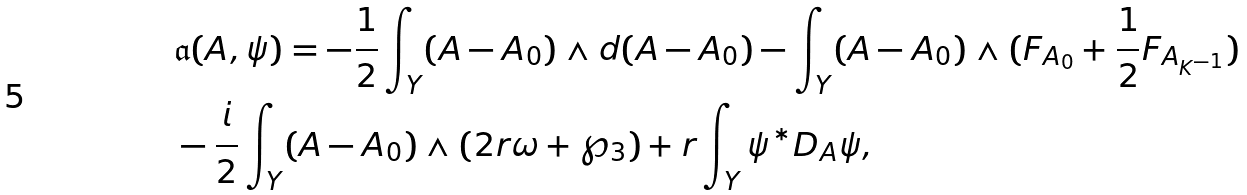Convert formula to latex. <formula><loc_0><loc_0><loc_500><loc_500>& \mathfrak { a } ( A , \psi ) = - \frac { 1 } { 2 } \int _ { Y } ( A - A _ { 0 } ) \wedge d ( A - A _ { 0 } ) - \int _ { Y } ( A - A _ { 0 } ) \wedge ( F _ { A _ { 0 } } + \frac { 1 } { 2 } F _ { A _ { K ^ { - 1 } } } ) \\ & - \frac { i } { 2 } \int _ { Y } ( A - A _ { 0 } ) \wedge ( 2 r \omega + \wp _ { 3 } ) + r \int _ { Y } \psi ^ { * } D _ { A } \psi ,</formula> 